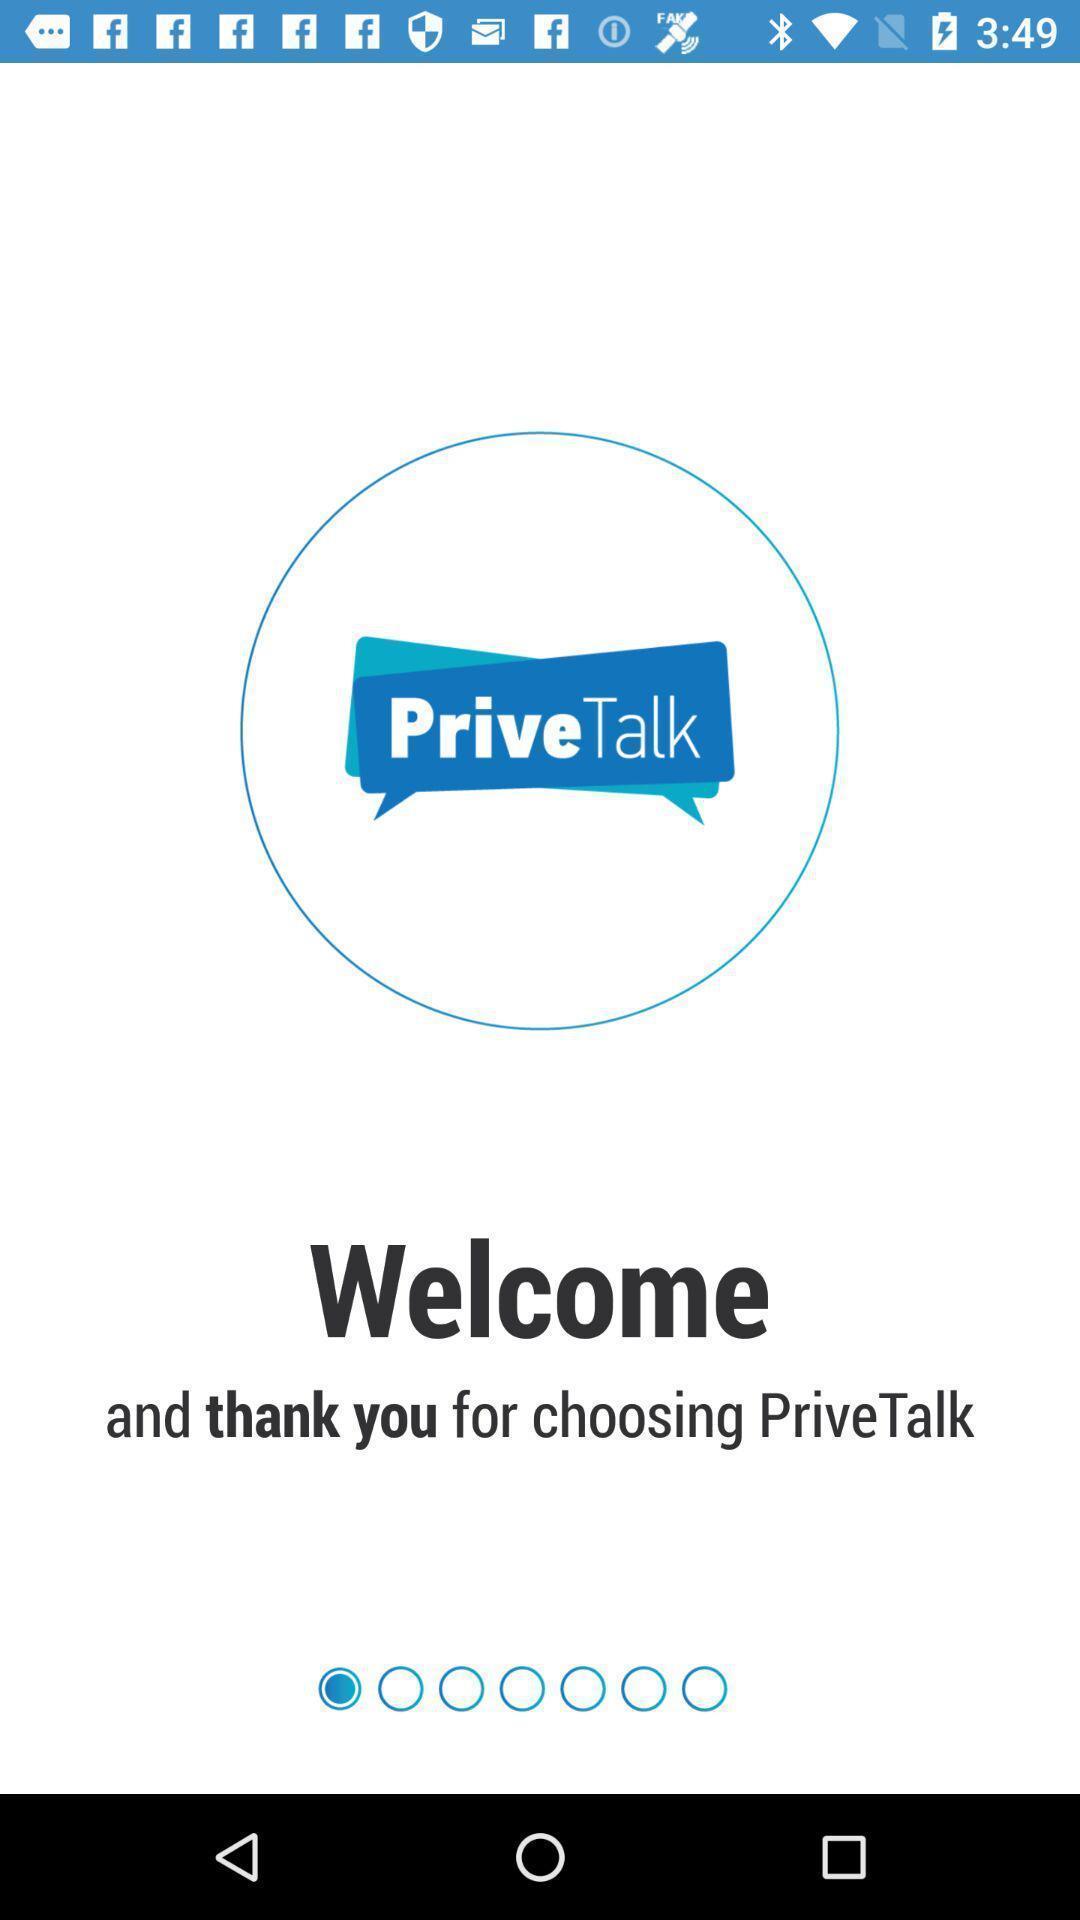Tell me what you see in this picture. Welcome page to the application. 